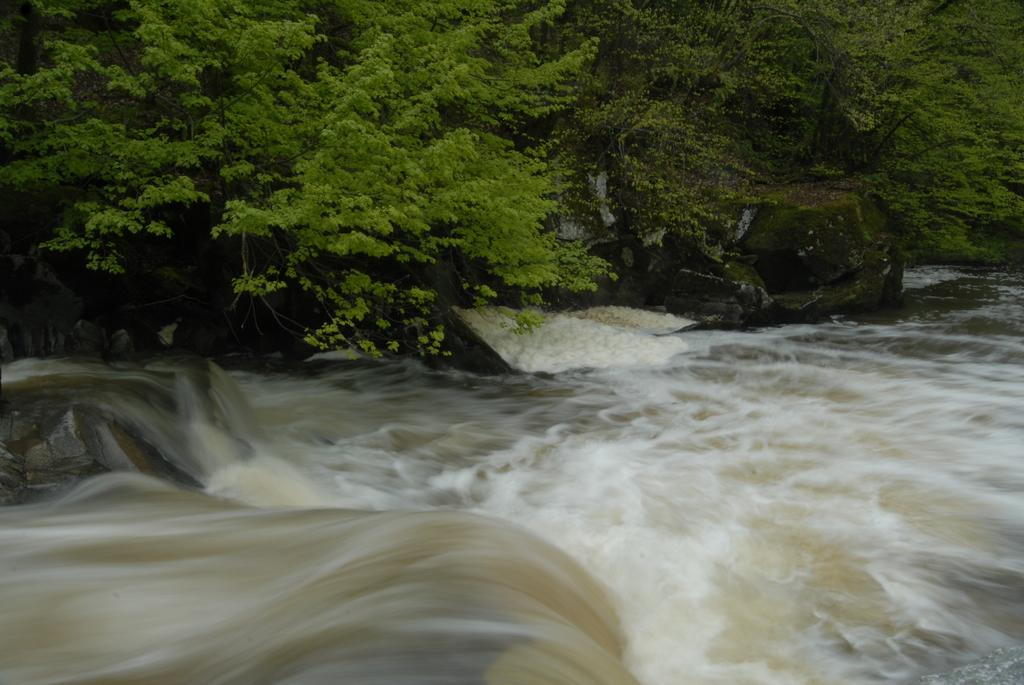What is happening to the water in the image? The water is flowing on rocks in the image. What can be seen in the background of the image? There are trees visible in the background of the image. What scent can be detected from the water in the image? There is no information about the scent of the water in the image, as it is a visual representation. 